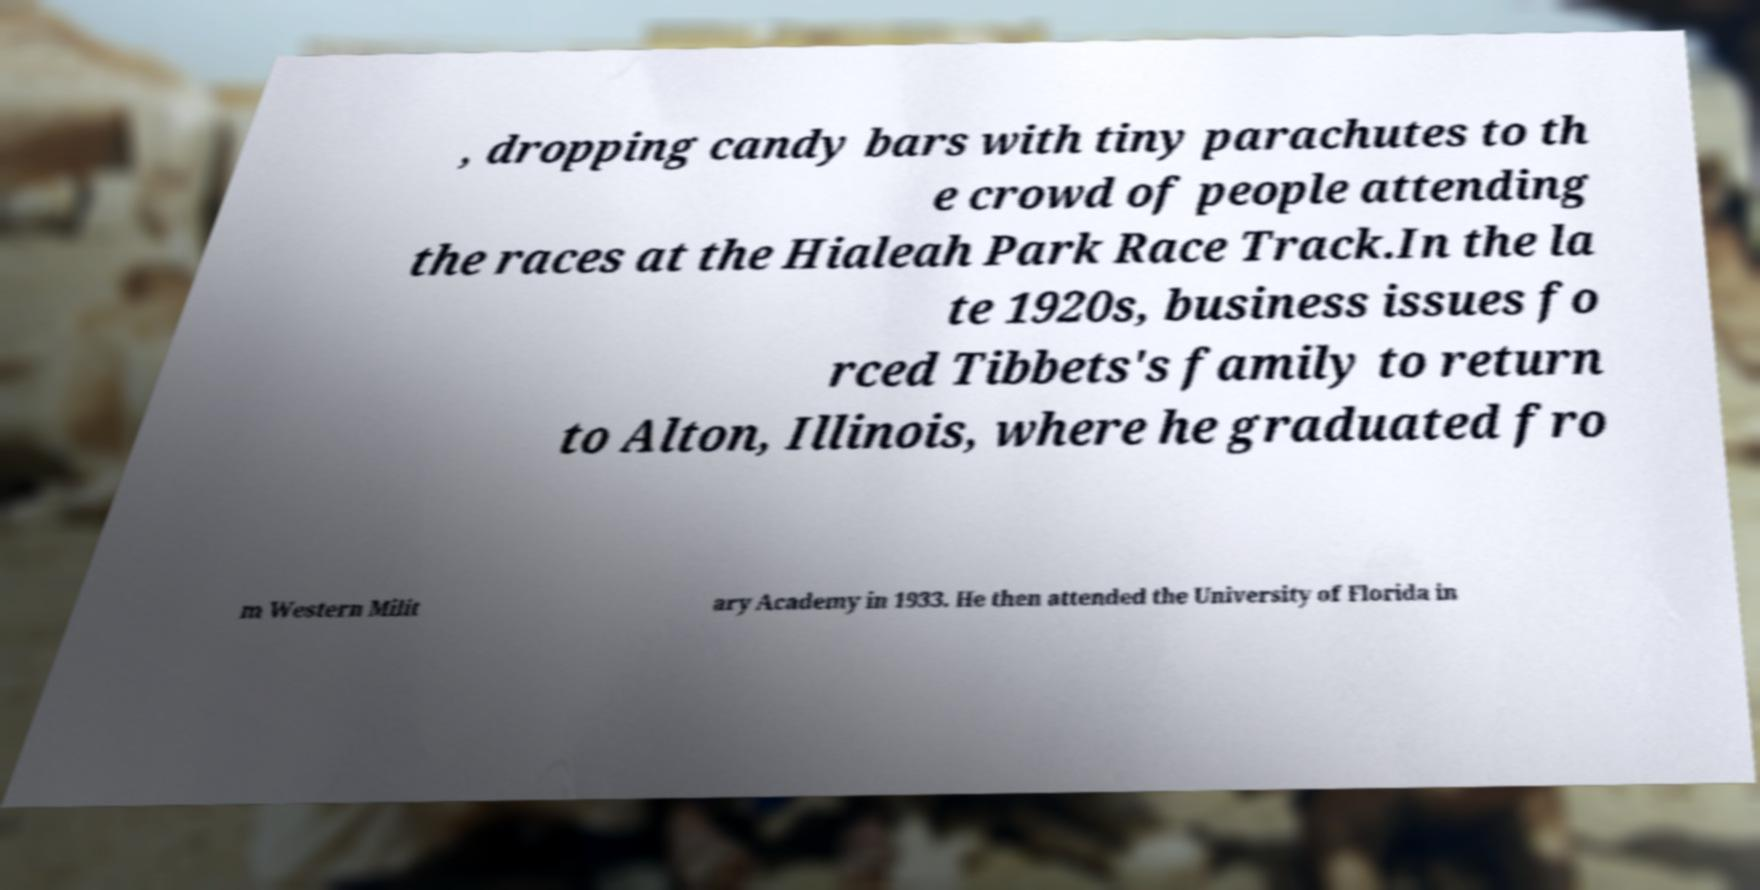Can you accurately transcribe the text from the provided image for me? , dropping candy bars with tiny parachutes to th e crowd of people attending the races at the Hialeah Park Race Track.In the la te 1920s, business issues fo rced Tibbets's family to return to Alton, Illinois, where he graduated fro m Western Milit ary Academy in 1933. He then attended the University of Florida in 